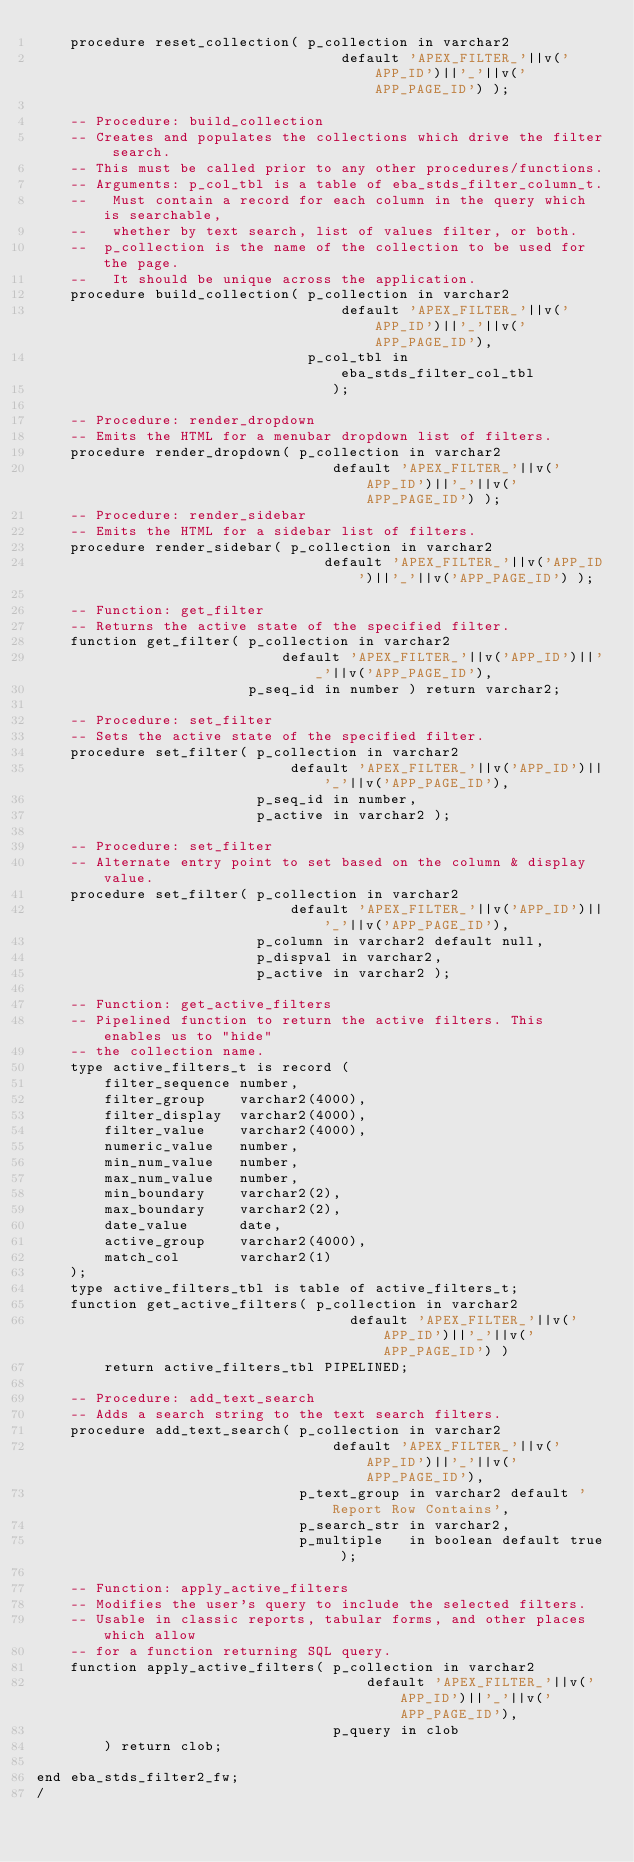<code> <loc_0><loc_0><loc_500><loc_500><_SQL_>    procedure reset_collection( p_collection in varchar2
                                    default 'APEX_FILTER_'||v('APP_ID')||'_'||v('APP_PAGE_ID') );

    -- Procedure: build_collection
    -- Creates and populates the collections which drive the filter search.
    -- This must be called prior to any other procedures/functions.
    -- Arguments: p_col_tbl is a table of eba_stds_filter_column_t.
    --   Must contain a record for each column in the query which is searchable,
    --   whether by text search, list of values filter, or both.
    --  p_collection is the name of the collection to be used for the page.
    --   It should be unique across the application.
    procedure build_collection( p_collection in varchar2
                                    default 'APEX_FILTER_'||v('APP_ID')||'_'||v('APP_PAGE_ID'),
                                p_col_tbl in eba_stds_filter_col_tbl
                                   );

    -- Procedure: render_dropdown
    -- Emits the HTML for a menubar dropdown list of filters.
    procedure render_dropdown( p_collection in varchar2
                                   default 'APEX_FILTER_'||v('APP_ID')||'_'||v('APP_PAGE_ID') );
    -- Procedure: render_sidebar
    -- Emits the HTML for a sidebar list of filters.
    procedure render_sidebar( p_collection in varchar2
                                  default 'APEX_FILTER_'||v('APP_ID')||'_'||v('APP_PAGE_ID') );

    -- Function: get_filter
    -- Returns the active state of the specified filter.
    function get_filter( p_collection in varchar2
                             default 'APEX_FILTER_'||v('APP_ID')||'_'||v('APP_PAGE_ID'),
                         p_seq_id in number ) return varchar2;

    -- Procedure: set_filter
    -- Sets the active state of the specified filter.
    procedure set_filter( p_collection in varchar2
                              default 'APEX_FILTER_'||v('APP_ID')||'_'||v('APP_PAGE_ID'),
                          p_seq_id in number,
                          p_active in varchar2 );

    -- Procedure: set_filter
    -- Alternate entry point to set based on the column & display value.
    procedure set_filter( p_collection in varchar2
                              default 'APEX_FILTER_'||v('APP_ID')||'_'||v('APP_PAGE_ID'),
                          p_column in varchar2 default null,
                          p_dispval in varchar2,
                          p_active in varchar2 );

    -- Function: get_active_filters
    -- Pipelined function to return the active filters. This enables us to "hide"
    -- the collection name.
    type active_filters_t is record (
        filter_sequence number,
        filter_group    varchar2(4000),
        filter_display  varchar2(4000),
        filter_value    varchar2(4000),
        numeric_value   number,
        min_num_value   number,
        max_num_value   number,
        min_boundary    varchar2(2),
        max_boundary    varchar2(2),
        date_value      date,
        active_group    varchar2(4000),
        match_col       varchar2(1)
    );
    type active_filters_tbl is table of active_filters_t;
    function get_active_filters( p_collection in varchar2
                                     default 'APEX_FILTER_'||v('APP_ID')||'_'||v('APP_PAGE_ID') )
        return active_filters_tbl PIPELINED;

    -- Procedure: add_text_search
    -- Adds a search string to the text search filters.
    procedure add_text_search( p_collection in varchar2
                                   default 'APEX_FILTER_'||v('APP_ID')||'_'||v('APP_PAGE_ID'),
                               p_text_group in varchar2 default 'Report Row Contains',
                               p_search_str in varchar2,
                               p_multiple   in boolean default true );

    -- Function: apply_active_filters
    -- Modifies the user's query to include the selected filters.
    -- Usable in classic reports, tabular forms, and other places which allow
    -- for a function returning SQL query.
    function apply_active_filters( p_collection in varchar2
                                       default 'APEX_FILTER_'||v('APP_ID')||'_'||v('APP_PAGE_ID'),
                                   p_query in clob
        ) return clob;

end eba_stds_filter2_fw;
/</code> 